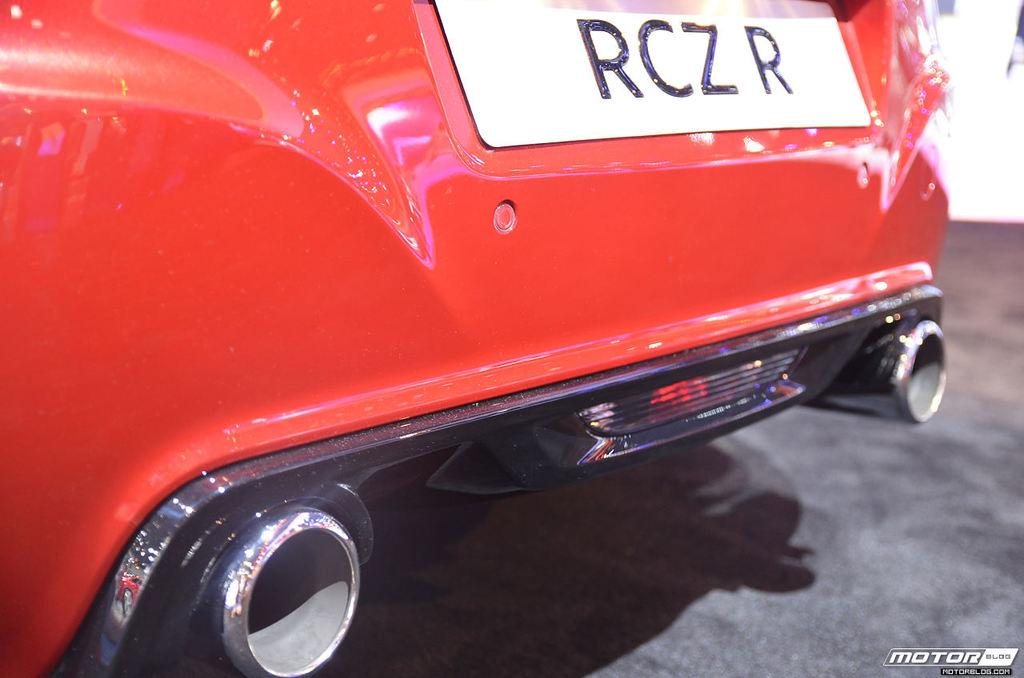What color is the car in the image? The car in the image is red. Does the car have any identifying features? Yes, the car has a number plate. What else can be seen in the image besides the car? There is a watermark on the right side of the image. What emotion is the car displaying in the image? Cars do not display emotions, so this question cannot be answered. 